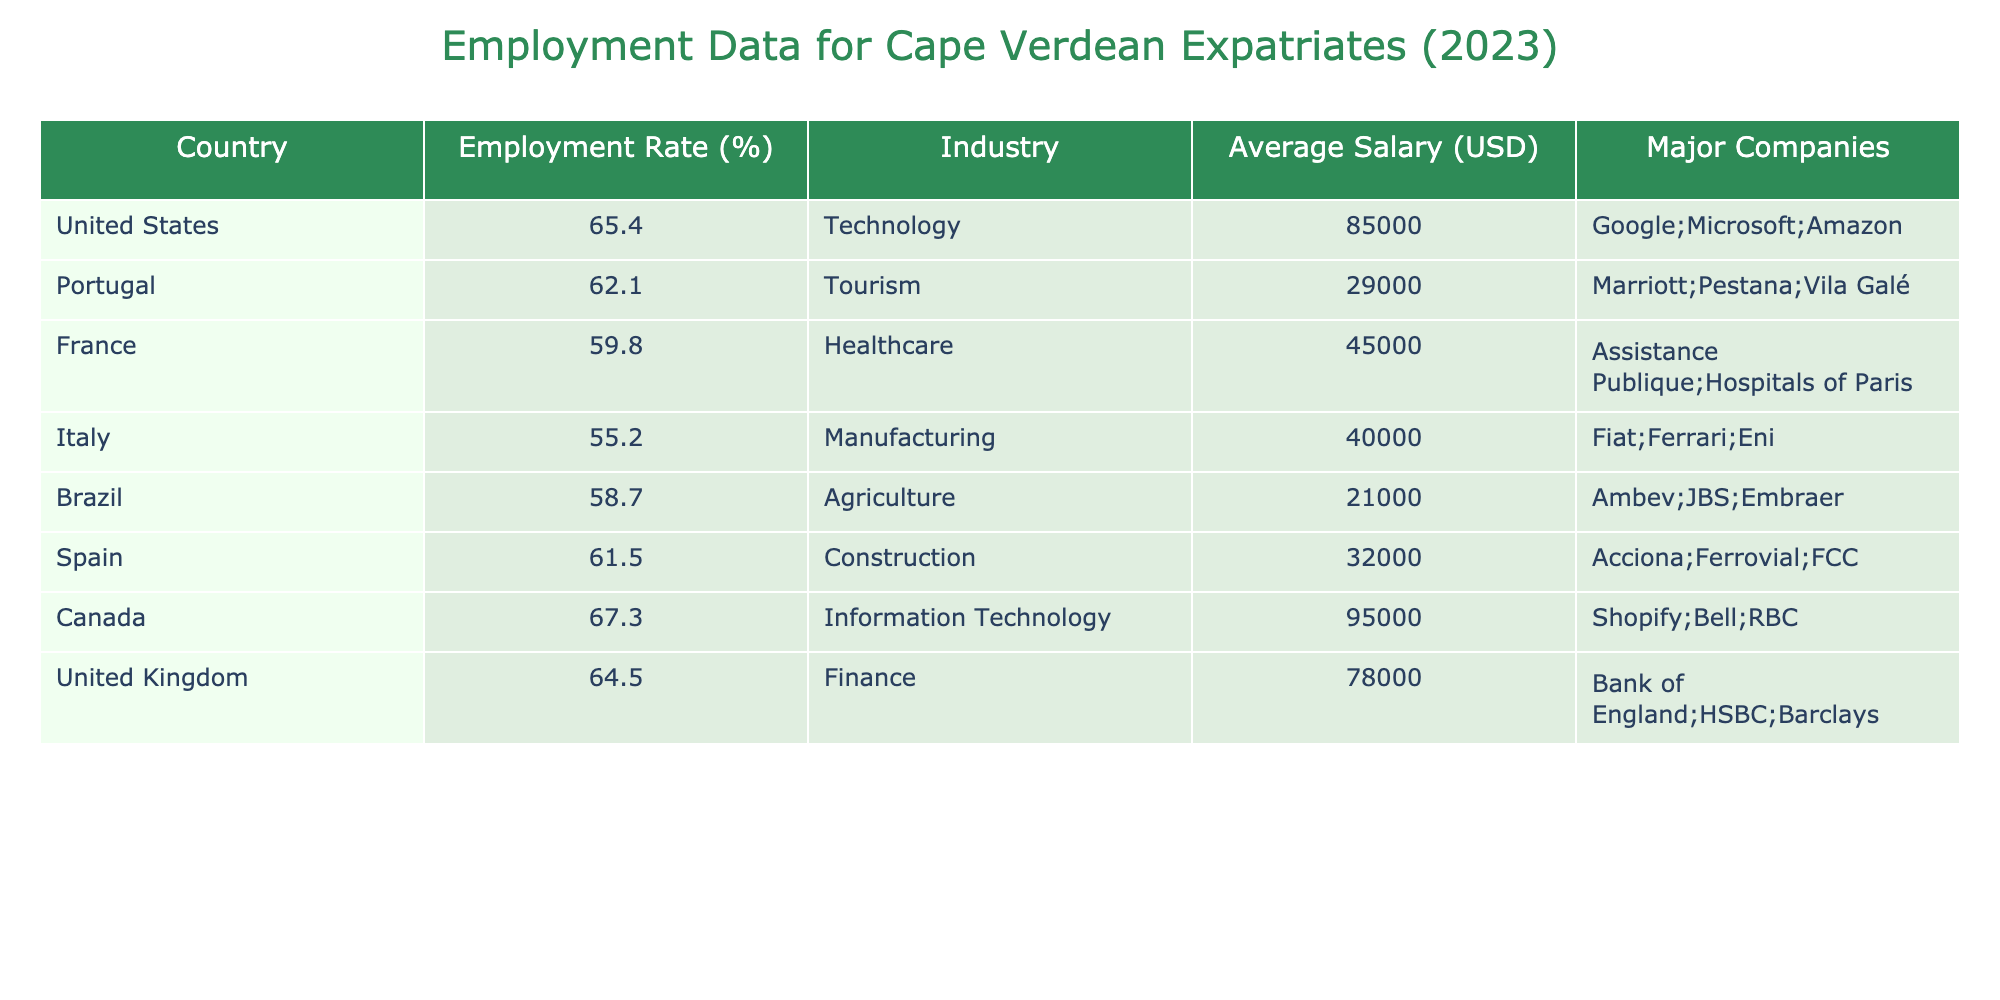What's the employment rate of Cape Verdean expatriates in Canada? The table indicates that the employment rate in Canada is listed as 67.3%.
Answer: 67.3% Which country has the lowest employment rate for Cape Verdean expatriates? By examining the employment rates in the table, we see that Italy has the lowest rate at 55.2%.
Answer: Italy What is the average salary for Cape Verdean expatriates working in France? The table shows that the average salary in France is 45,000 USD.
Answer: 45,000 USD If we average the employment rates of Cape Verdean expatriates across all countries listed, what is the result? To calculate the average, sum all employment rates: (65.4 + 62.1 + 59.8 + 55.2 + 58.7 + 61.5 + 67.3 + 64.5) =  450.5. There are 8 countries, so we divide 450.5 by 8, which equals 56.3125. Rounding gives approximately 56.31%.
Answer: 56.31% Do any of the countries listed have an employment rate above 60%? Yes, by checking the employment rates, we find that the United States, Canada, United Kingdom, and Spain have rates above 60%.
Answer: Yes Which industry has the highest average salary for Cape Verdean expatriates? The table indicates that the Technology industry, under Canada, has the highest average salary of 95,000 USD.
Answer: Technology What percentage difference in employment rates exists between Portugal and Brazil? The employment rate in Portugal is 62.1% and in Brazil is 58.7%. The difference is 62.1 - 58.7 = 3.4%.
Answer: 3.4% Is the average salary of expatriates in Spain higher than in Portugal? Spain has an average salary of 32,000 USD, while Portugal's average is 29,000 USD. Since 32,000 is higher than 29,000, the statement is true.
Answer: Yes What are the major companies associated with the healthcare industry for Cape Verdean expatriates? The table indicates that in France, the major companies in the healthcare industry include Assistance Publique and Hospitals of Paris.
Answer: Assistance Publique; Hospitals of Paris 